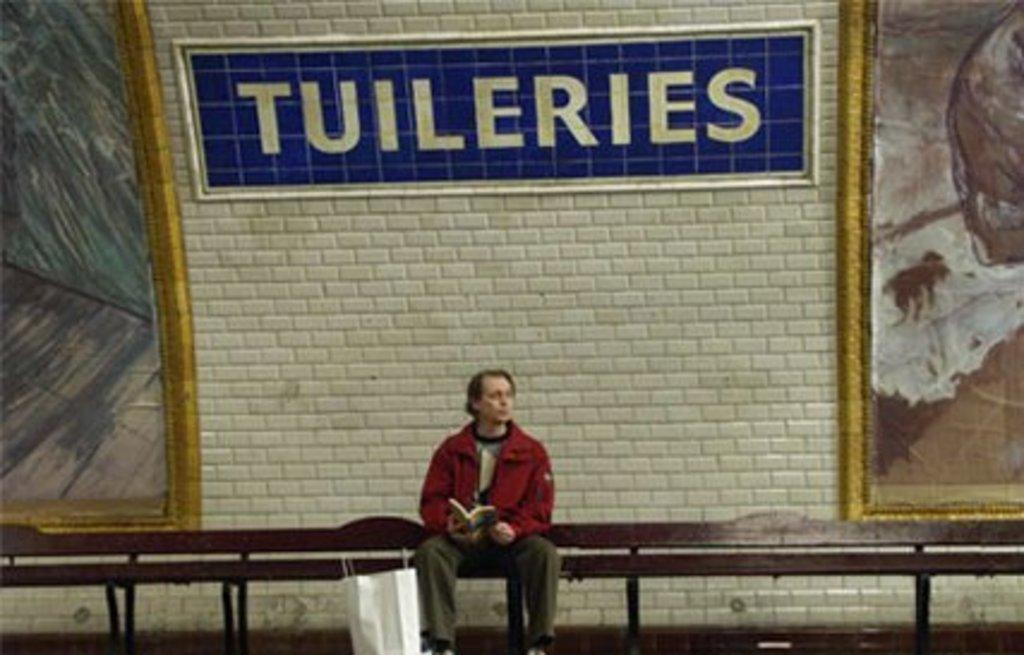Who is in the image? There is a man in the image. What is the man holding? The man is holding a book. Where is the man sitting? The man is sitting on a bench. What is located beside the man? There is a bag beside the man. What can be seen in the background of the image? There is a wall in the background of the image. Can you describe the design on the wall? There is a design on the wall, but the specifics are not mentioned in the provided facts. How does the man achieve harmony with his elbow in the image? There is no mention of harmony or elbows in the image, so this question cannot be answered definitively. 